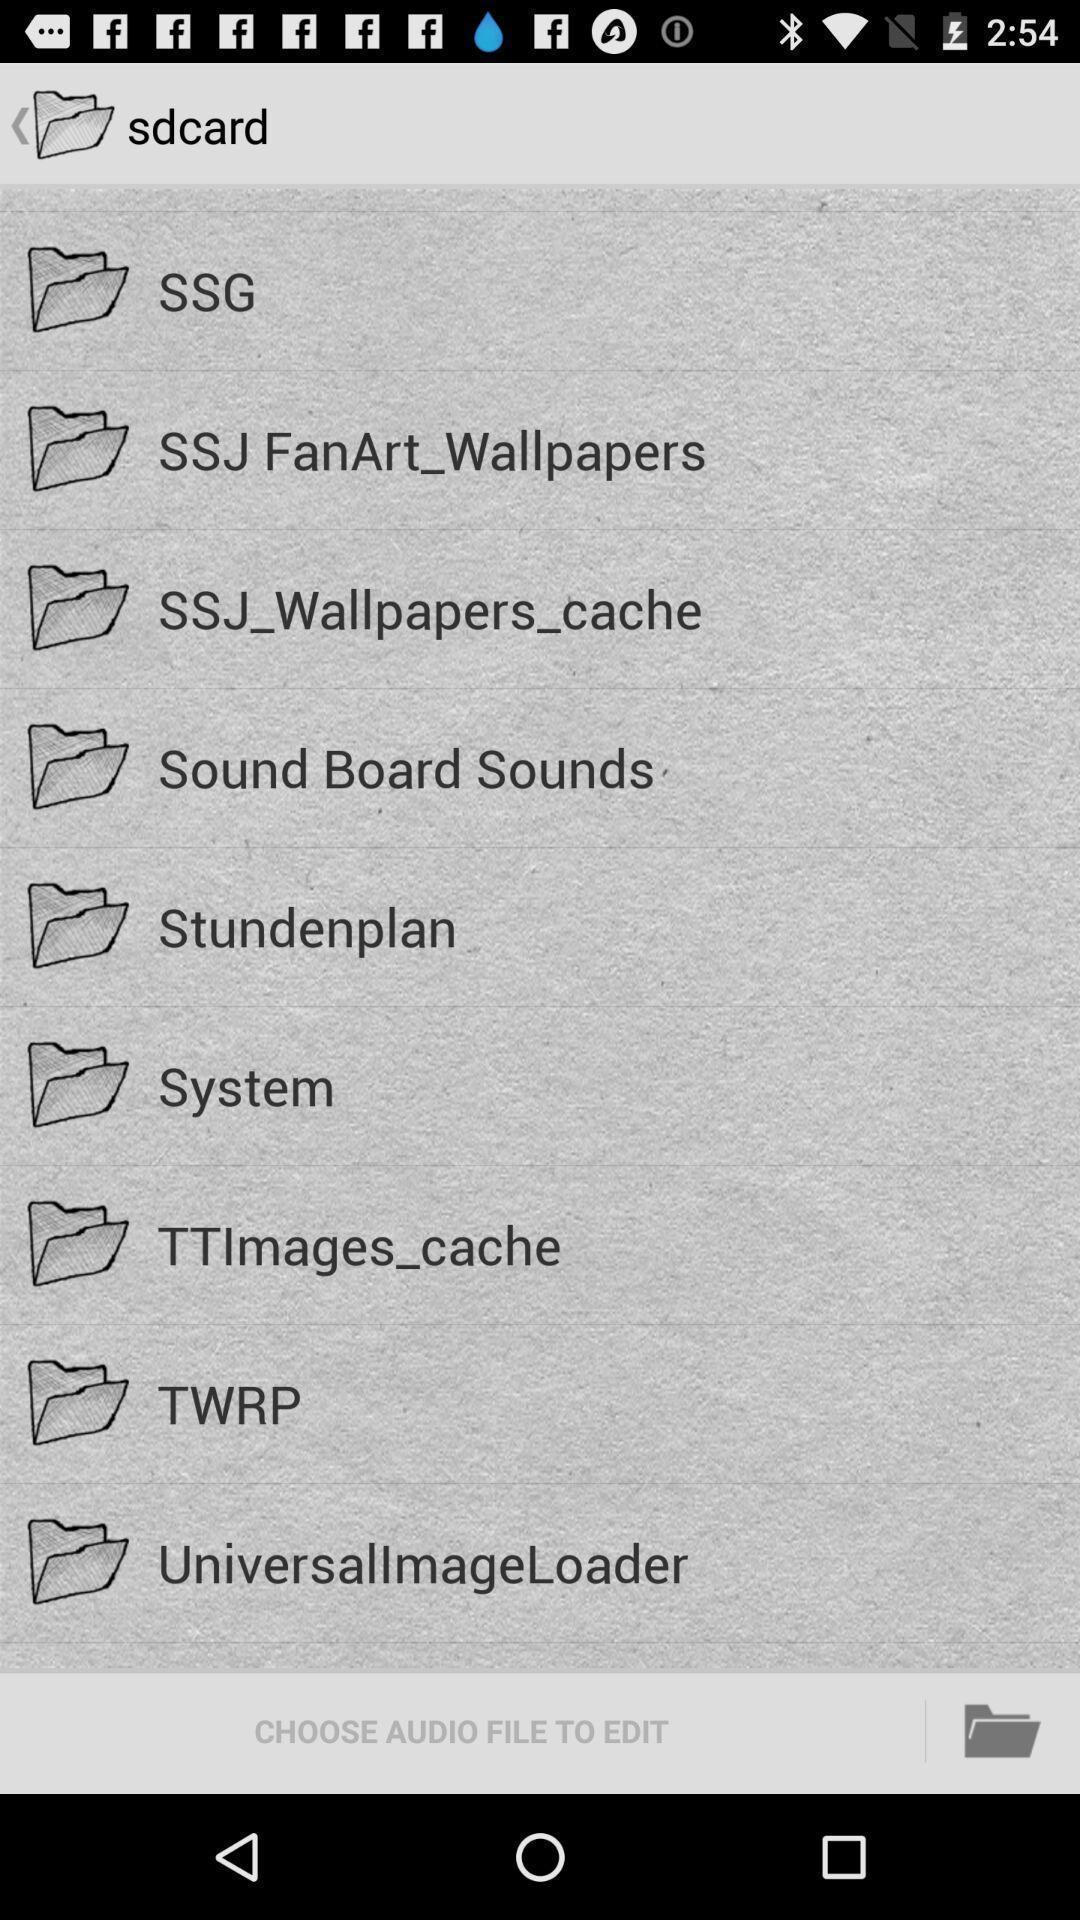Explain the elements present in this screenshot. Screen shows different options in ringtone maker app. 